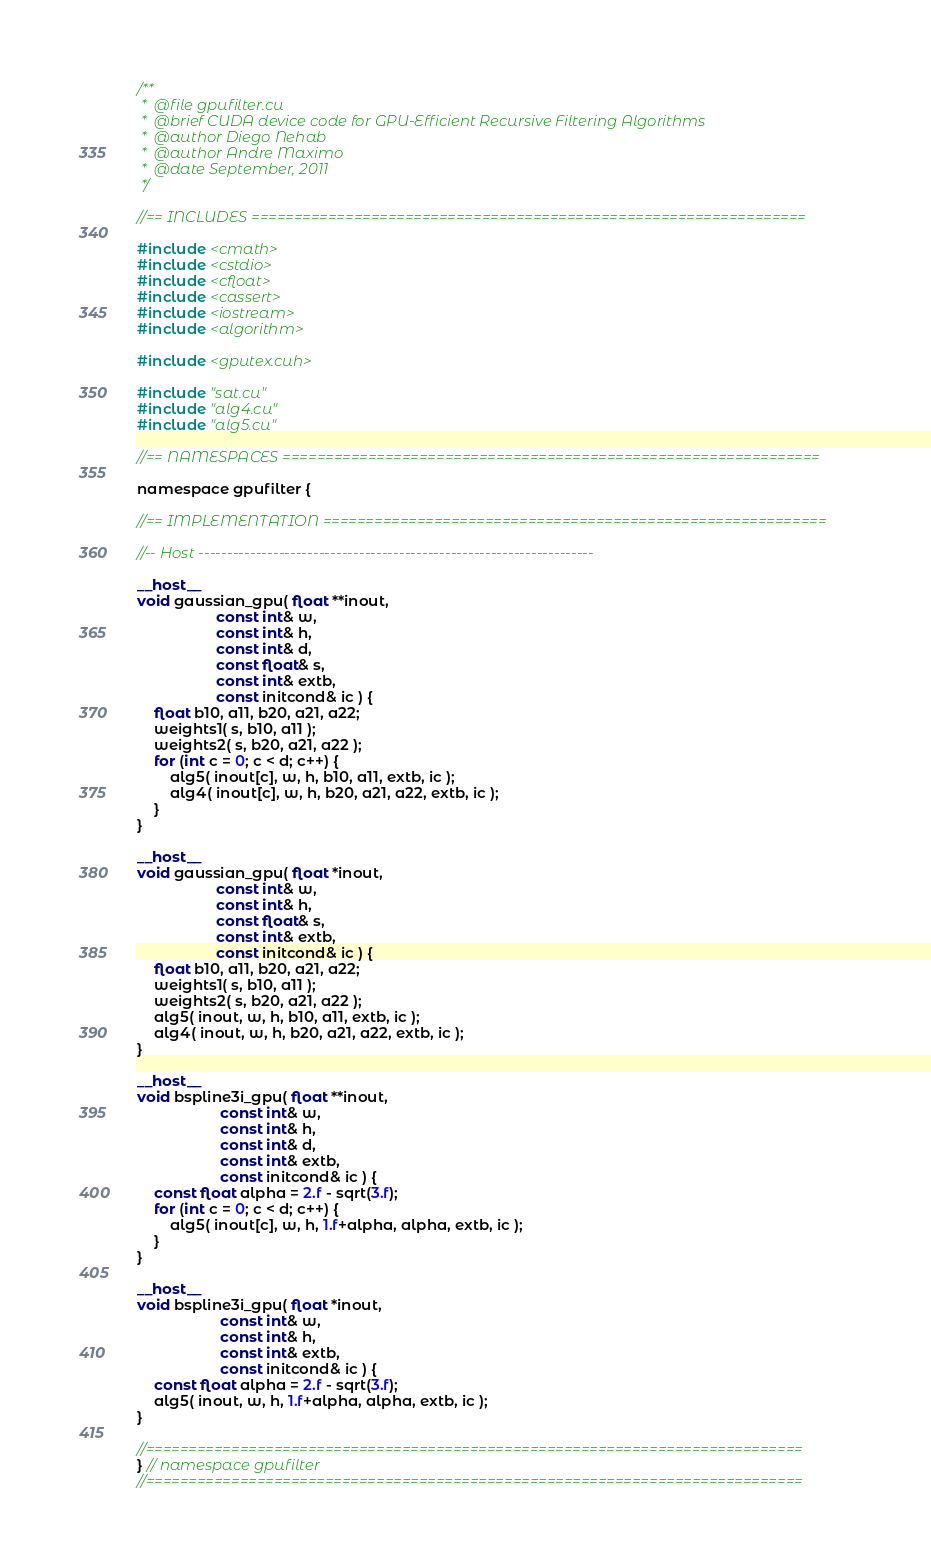<code> <loc_0><loc_0><loc_500><loc_500><_Cuda_>/**
 *  @file gpufilter.cu
 *  @brief CUDA device code for GPU-Efficient Recursive Filtering Algorithms
 *  @author Diego Nehab
 *  @author Andre Maximo
 *  @date September, 2011
 */

//== INCLUDES =================================================================

#include <cmath>
#include <cstdio>
#include <cfloat>
#include <cassert>
#include <iostream>
#include <algorithm>

#include <gputex.cuh>

#include "sat.cu"
#include "alg4.cu"
#include "alg5.cu"

//== NAMESPACES ===============================================================

namespace gpufilter {

//== IMPLEMENTATION ===========================================================

//-- Host ---------------------------------------------------------------------

__host__
void gaussian_gpu( float **inout,
                   const int& w,
                   const int& h,
                   const int& d,
                   const float& s,
                   const int& extb,
                   const initcond& ic ) {
    float b10, a11, b20, a21, a22;
    weights1( s, b10, a11 );
    weights2( s, b20, a21, a22 );
    for (int c = 0; c < d; c++) {
        alg5( inout[c], w, h, b10, a11, extb, ic );
        alg4( inout[c], w, h, b20, a21, a22, extb, ic );
    }
}

__host__
void gaussian_gpu( float *inout,
                   const int& w,
                   const int& h,
                   const float& s,
                   const int& extb,
                   const initcond& ic ) {
    float b10, a11, b20, a21, a22;
    weights1( s, b10, a11 );
    weights2( s, b20, a21, a22 );
    alg5( inout, w, h, b10, a11, extb, ic );
    alg4( inout, w, h, b20, a21, a22, extb, ic );
}

__host__
void bspline3i_gpu( float **inout,
                    const int& w,
                    const int& h,
                    const int& d,
                    const int& extb,
                    const initcond& ic ) {
    const float alpha = 2.f - sqrt(3.f);
    for (int c = 0; c < d; c++) {
        alg5( inout[c], w, h, 1.f+alpha, alpha, extb, ic );
    }
}

__host__
void bspline3i_gpu( float *inout,
                    const int& w,
                    const int& h,
                    const int& extb,
                    const initcond& ic ) {
    const float alpha = 2.f - sqrt(3.f);
    alg5( inout, w, h, 1.f+alpha, alpha, extb, ic );
}

//=============================================================================
} // namespace gpufilter
//=============================================================================
</code> 